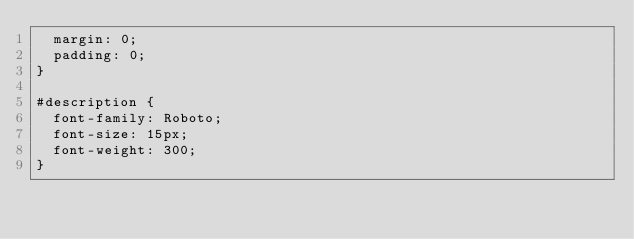<code> <loc_0><loc_0><loc_500><loc_500><_CSS_>  margin: 0;
  padding: 0;
}

#description {
  font-family: Roboto;
  font-size: 15px;
  font-weight: 300;
}
</code> 